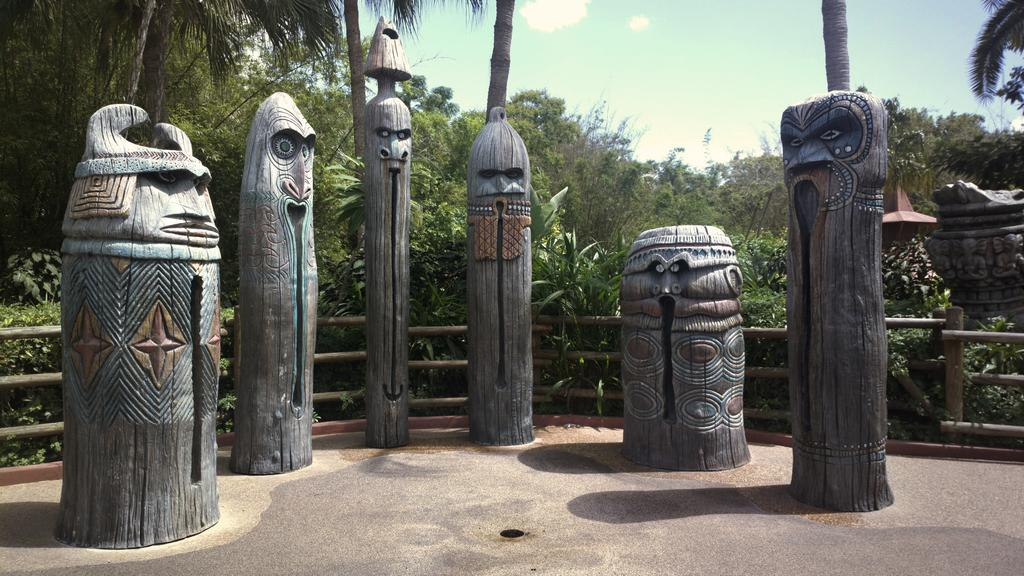What type of artwork is featured in the image? There are wood carvings in the image. What is the surface on which the wood carvings are placed? There is a floor at the bottom of the image. What can be seen in the background of the image? There are plants and trees, as well as a railing, in the background of the image. What type of class is being taught in the image? There is no class or teaching activity depicted in the image; it features wood carvings and a floor with plants and trees in the background. How many laborers are working on the wood carvings in the image? There is no indication of laborers or any work being done on the wood carvings in the image; it simply shows the finished carvings. 